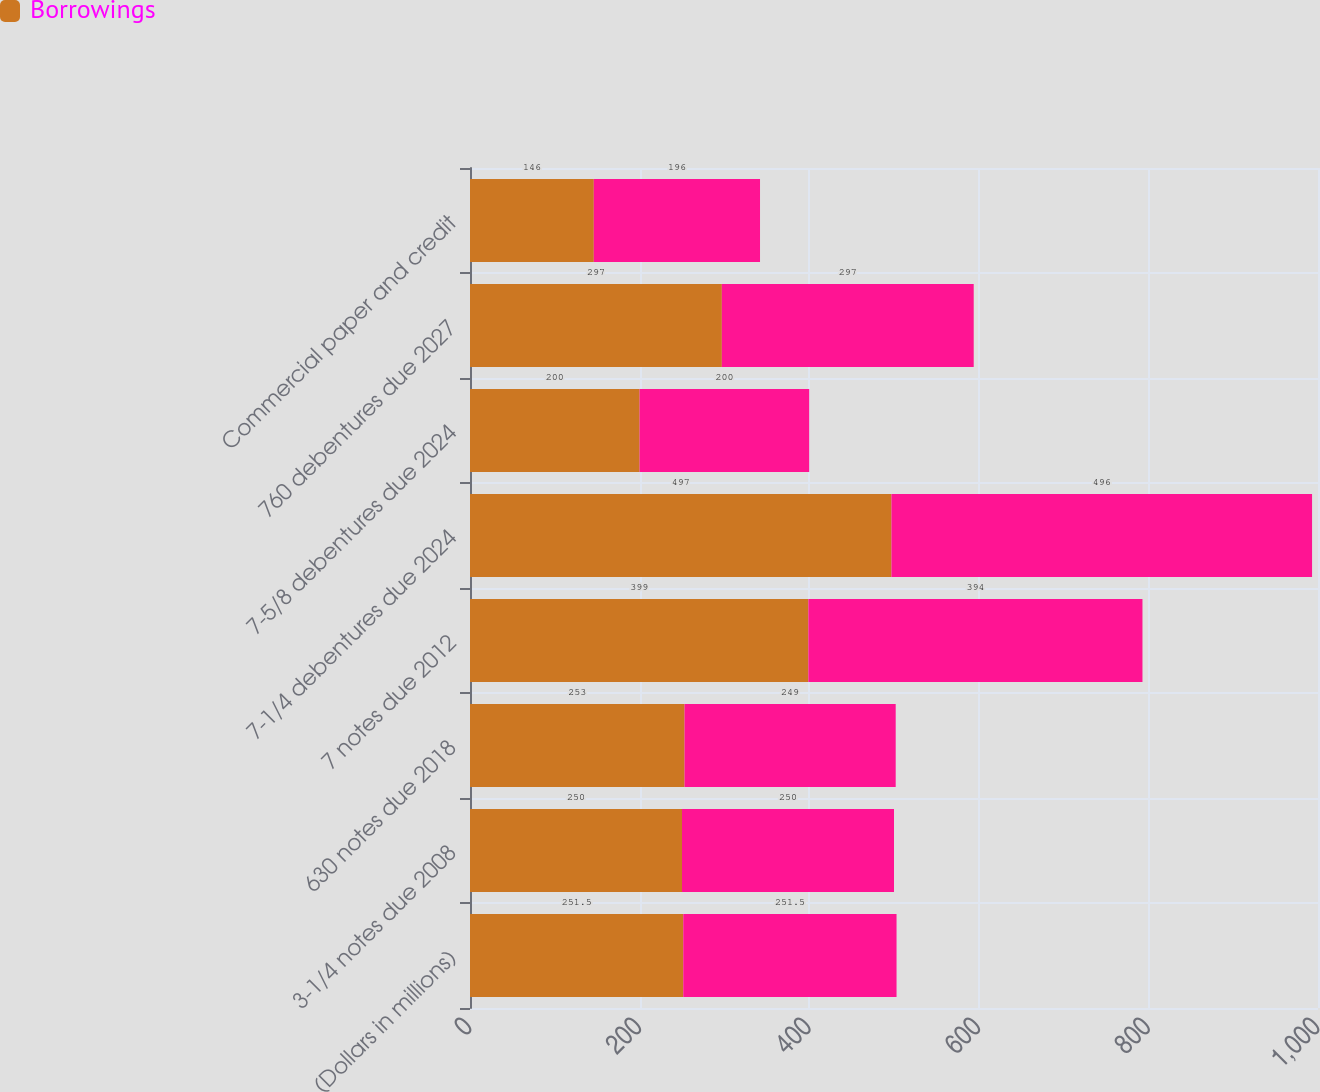Convert chart. <chart><loc_0><loc_0><loc_500><loc_500><stacked_bar_chart><ecel><fcel>(Dollars in millions)<fcel>3-1/4 notes due 2008<fcel>630 notes due 2018<fcel>7 notes due 2012<fcel>7-1/4 debentures due 2024<fcel>7-5/8 debentures due 2024<fcel>760 debentures due 2027<fcel>Commercial paper and credit<nl><fcel>Borrowings<fcel>251.5<fcel>250<fcel>253<fcel>399<fcel>497<fcel>200<fcel>297<fcel>146<nl><fcel>nan<fcel>251.5<fcel>250<fcel>249<fcel>394<fcel>496<fcel>200<fcel>297<fcel>196<nl></chart> 